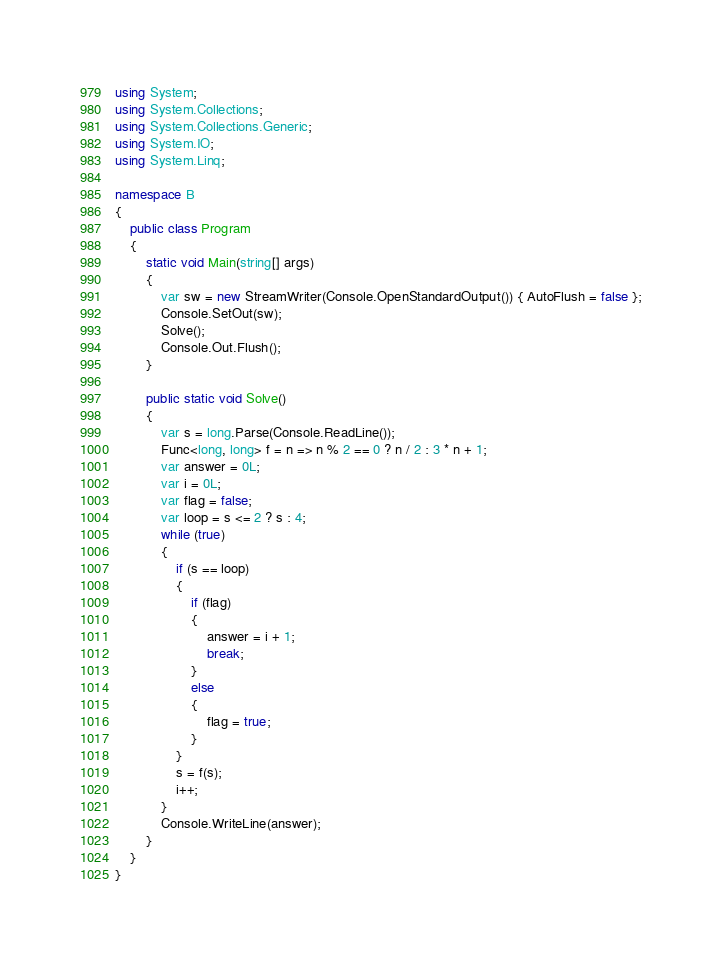Convert code to text. <code><loc_0><loc_0><loc_500><loc_500><_C#_>using System;
using System.Collections;
using System.Collections.Generic;
using System.IO;
using System.Linq;

namespace B
{
    public class Program
    {
        static void Main(string[] args)
        {
            var sw = new StreamWriter(Console.OpenStandardOutput()) { AutoFlush = false };
            Console.SetOut(sw);
            Solve();
            Console.Out.Flush();
        }

        public static void Solve()
        {
            var s = long.Parse(Console.ReadLine());
            Func<long, long> f = n => n % 2 == 0 ? n / 2 : 3 * n + 1;
            var answer = 0L;
            var i = 0L;
            var flag = false;
            var loop = s <= 2 ? s : 4;
            while (true)
            {
                if (s == loop)
                {
                    if (flag)
                    {
                        answer = i + 1;
                        break;
                    }
                    else
                    {
                        flag = true;
                    }
                }
                s = f(s);
                i++;
            }
            Console.WriteLine(answer);
        }
    }
}
</code> 